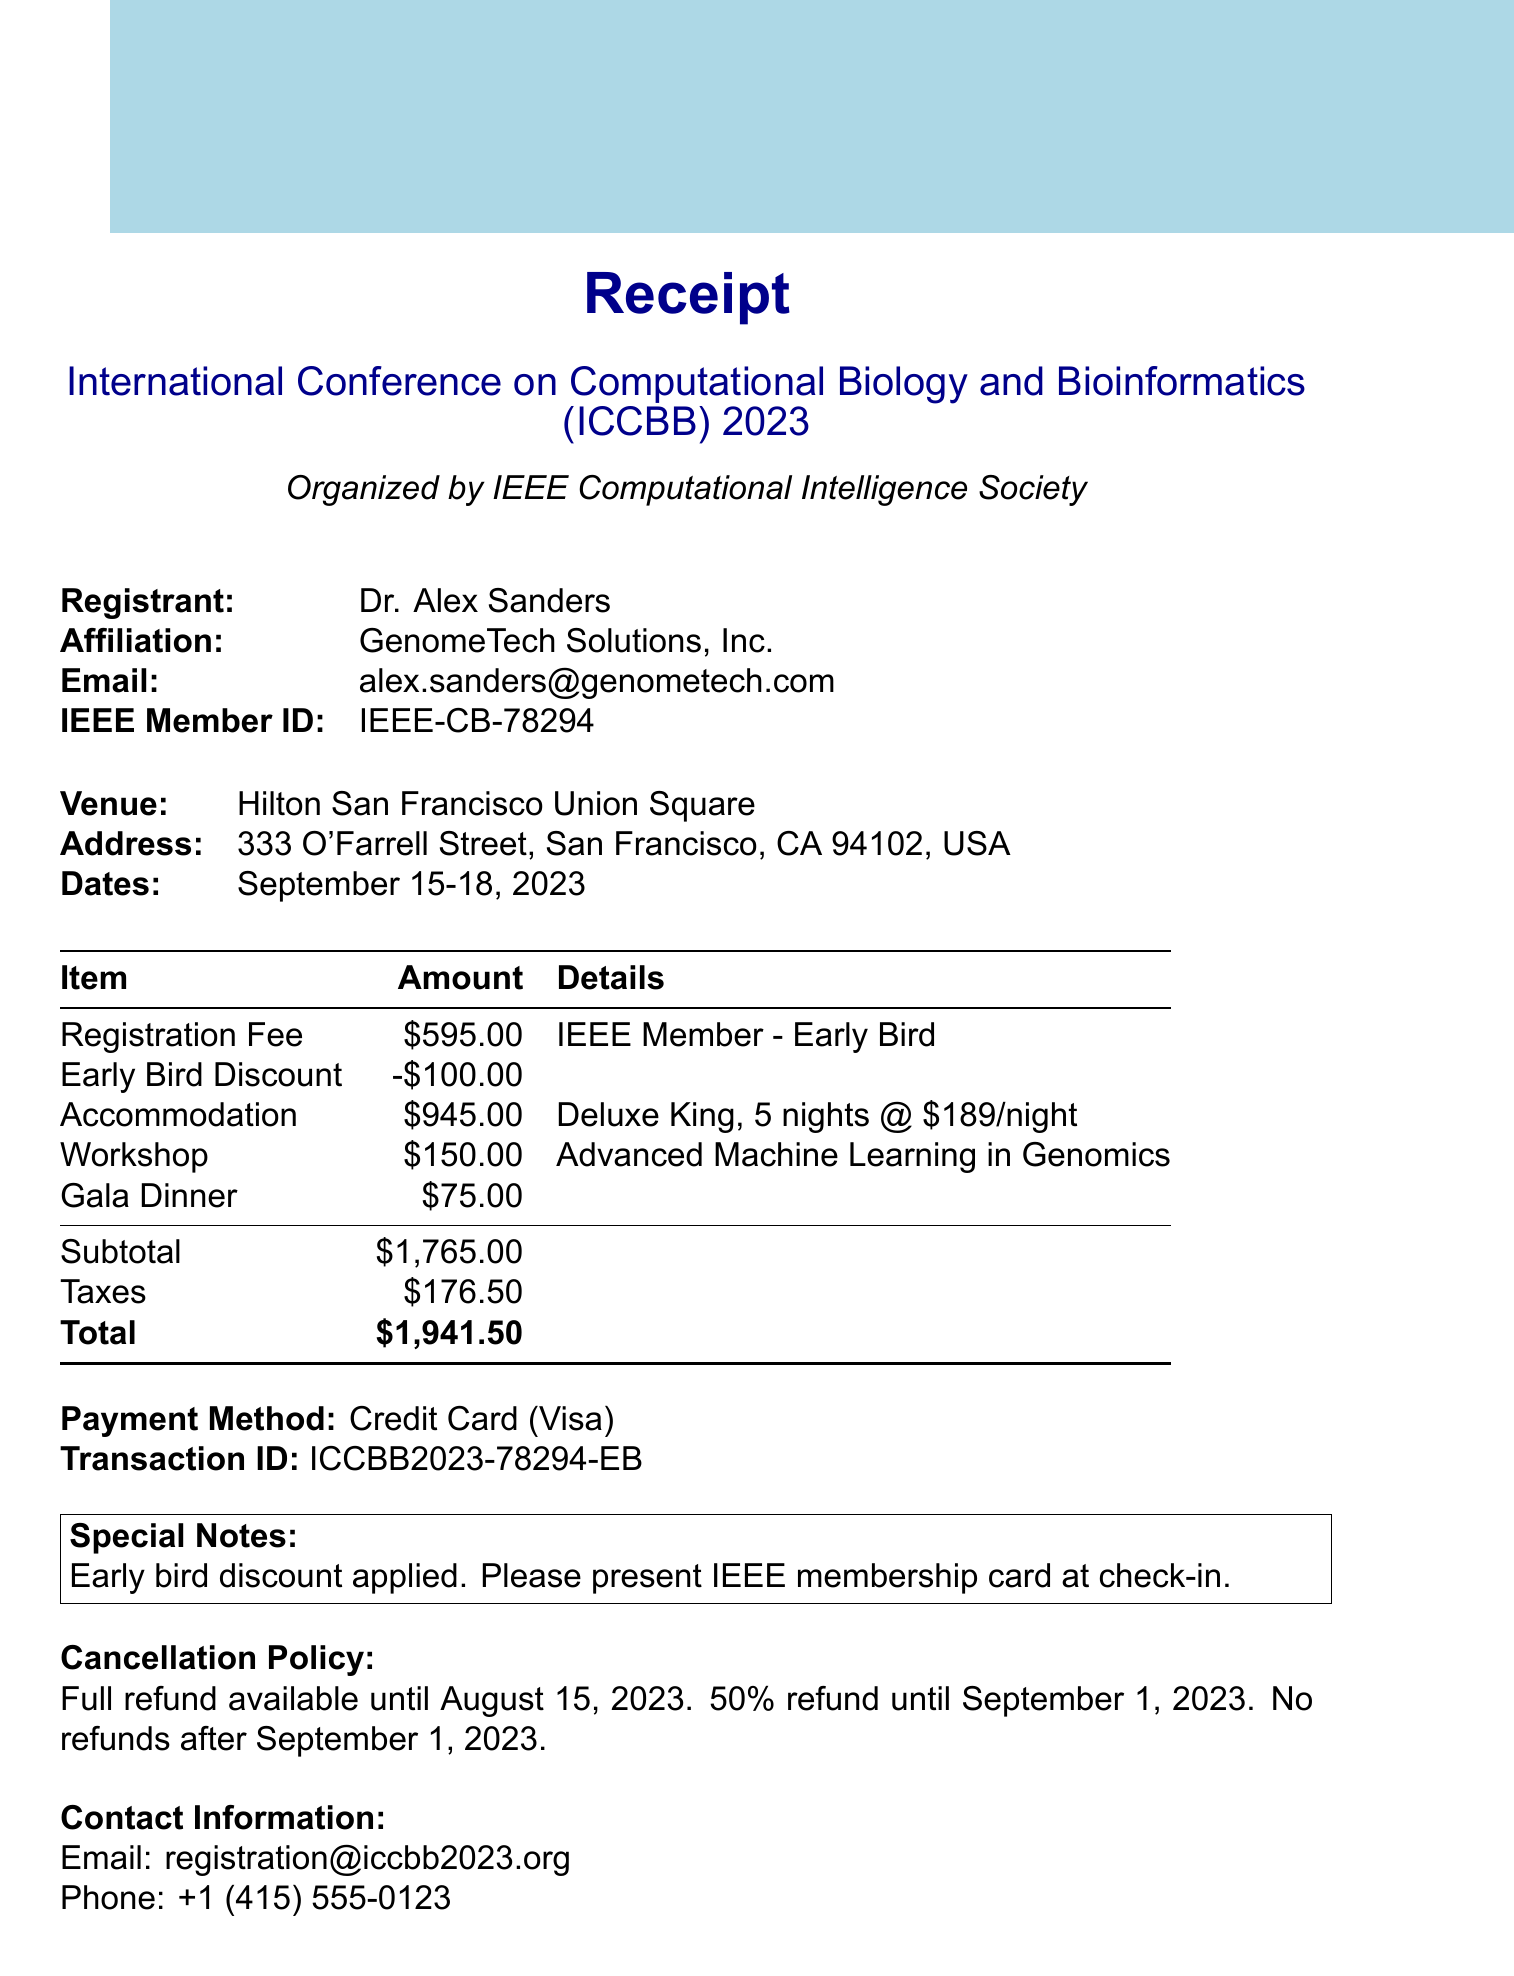What is the venue? The venue information is listed in the document, specifically indicating where the conference will take place.
Answer: Hilton San Francisco Union Square Who is the registrant? The document provides the name of the person who registered for the conference under the "Registrant" section.
Answer: Dr. Alex Sanders What is the total amount? The total amount is the final sum listed at the bottom of the receipt after calculating all items and taxes.
Answer: $1941.50 What is the check-out date for accommodation? The check-out date is specified in the accommodation section of the receipt.
Answer: 2023-09-19 How much is the early bird discount? The early bird discount is explicitly mentioned in the registration fee breakdown.
Answer: $100.00 What type of room was booked? The room type is detailed in the accommodation section of the receipt, indicating what kind of lodging was arranged.
Answer: Deluxe King What is the cancellation policy after September 1, 2023? The cancellation policy details are provided, indicating what happens regarding refunds after a certain date.
Answer: No refunds after September 1, 2023 What workshop is included? The document lists specific additional items, including workshops available for registrants, indicating which workshop has been selected.
Answer: Advanced Machine Learning in Genomics What payment method was used? The method of payment is stated clearly towards the end of the document, indicating how the registrant paid for the services.
Answer: Credit Card (Visa) 